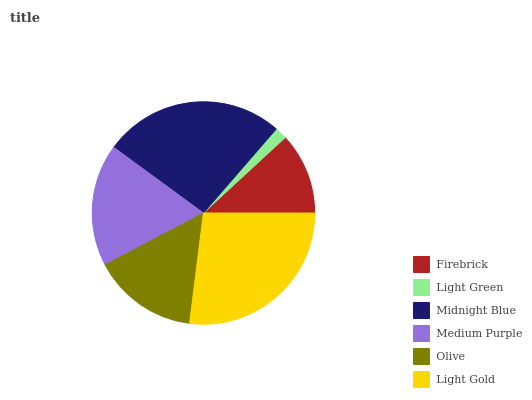Is Light Green the minimum?
Answer yes or no. Yes. Is Light Gold the maximum?
Answer yes or no. Yes. Is Midnight Blue the minimum?
Answer yes or no. No. Is Midnight Blue the maximum?
Answer yes or no. No. Is Midnight Blue greater than Light Green?
Answer yes or no. Yes. Is Light Green less than Midnight Blue?
Answer yes or no. Yes. Is Light Green greater than Midnight Blue?
Answer yes or no. No. Is Midnight Blue less than Light Green?
Answer yes or no. No. Is Medium Purple the high median?
Answer yes or no. Yes. Is Olive the low median?
Answer yes or no. Yes. Is Olive the high median?
Answer yes or no. No. Is Firebrick the low median?
Answer yes or no. No. 